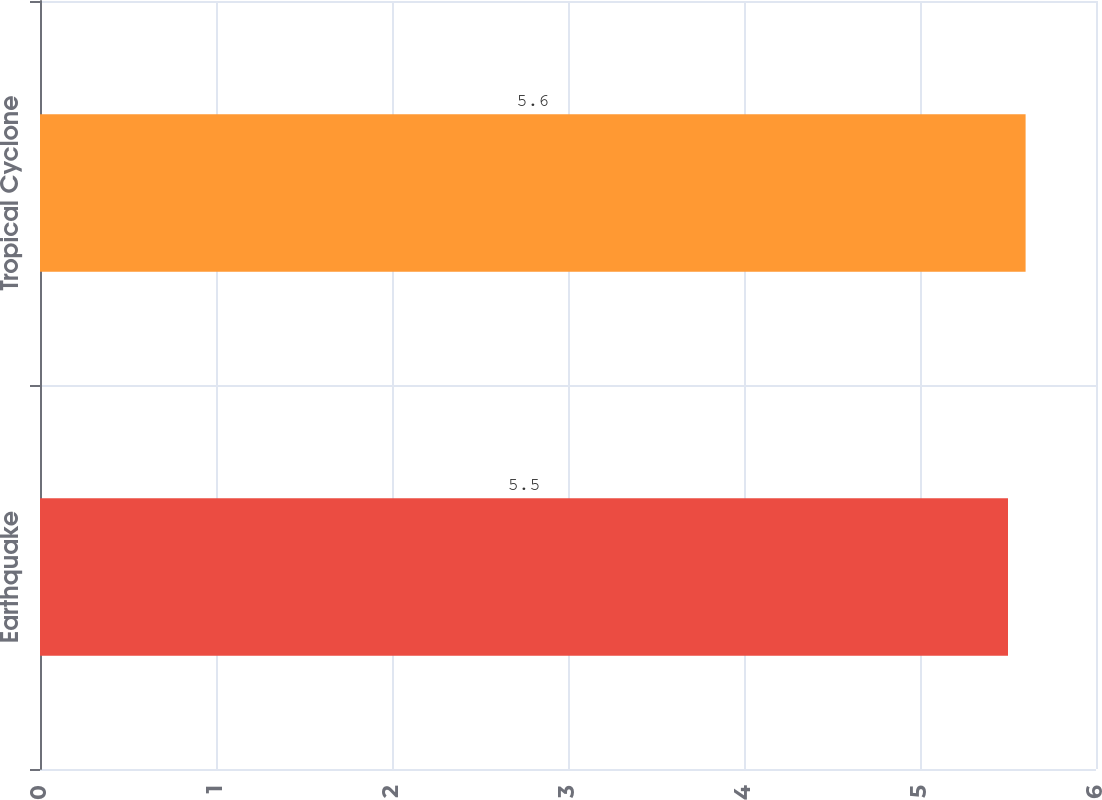Convert chart. <chart><loc_0><loc_0><loc_500><loc_500><bar_chart><fcel>Earthquake<fcel>Tropical Cyclone<nl><fcel>5.5<fcel>5.6<nl></chart> 